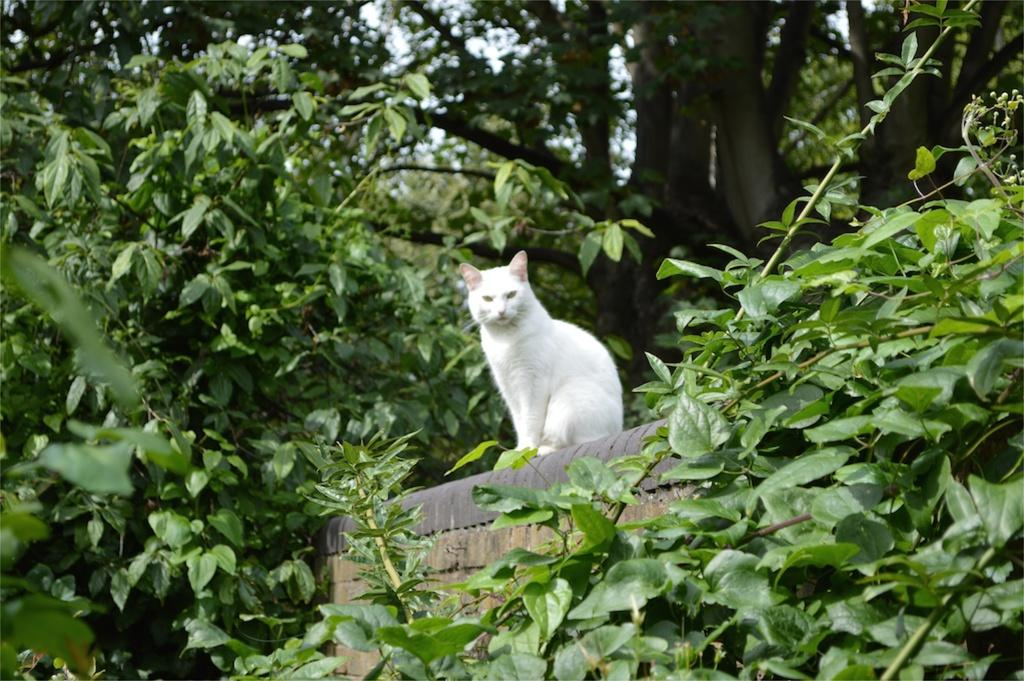What type of animal can be seen in the image? There is a white-colored cat in the image. Where is the cat located in the image? The cat is present on a wall. What type of natural elements are visible in the image? There are trees and plants visible in the image. What type of tank can be seen in the image? There is no tank present in the image. How many passengers are visible in the image? There are no passengers visible in the image. 